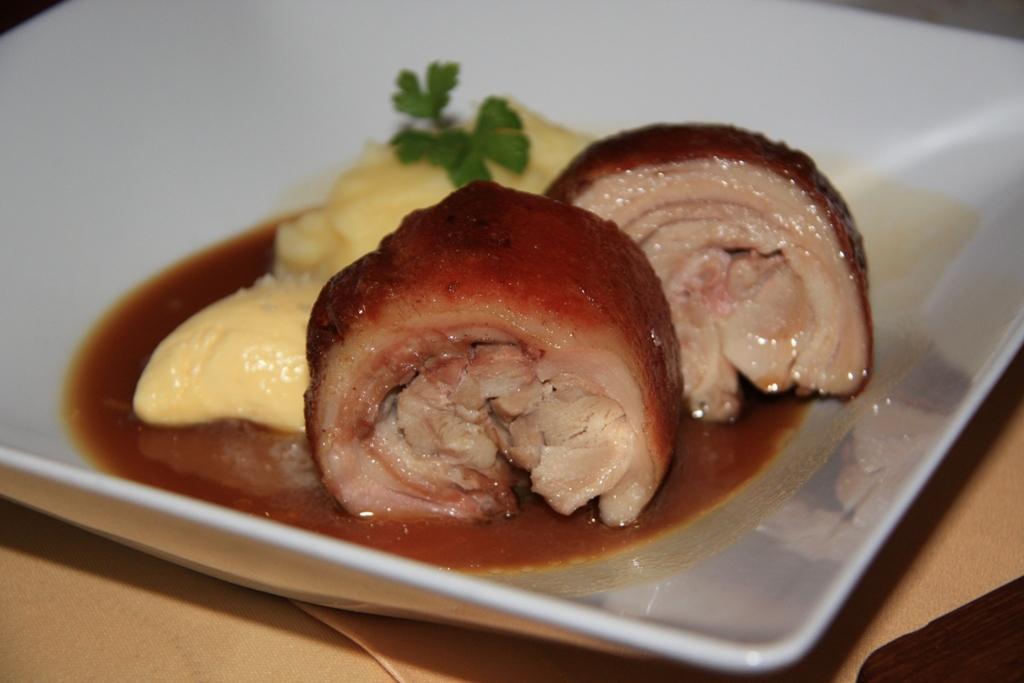Can you describe this image briefly? This image consists of meat kept in a plate. At the bottom, there is a tablecloth. The plate is in white color. 